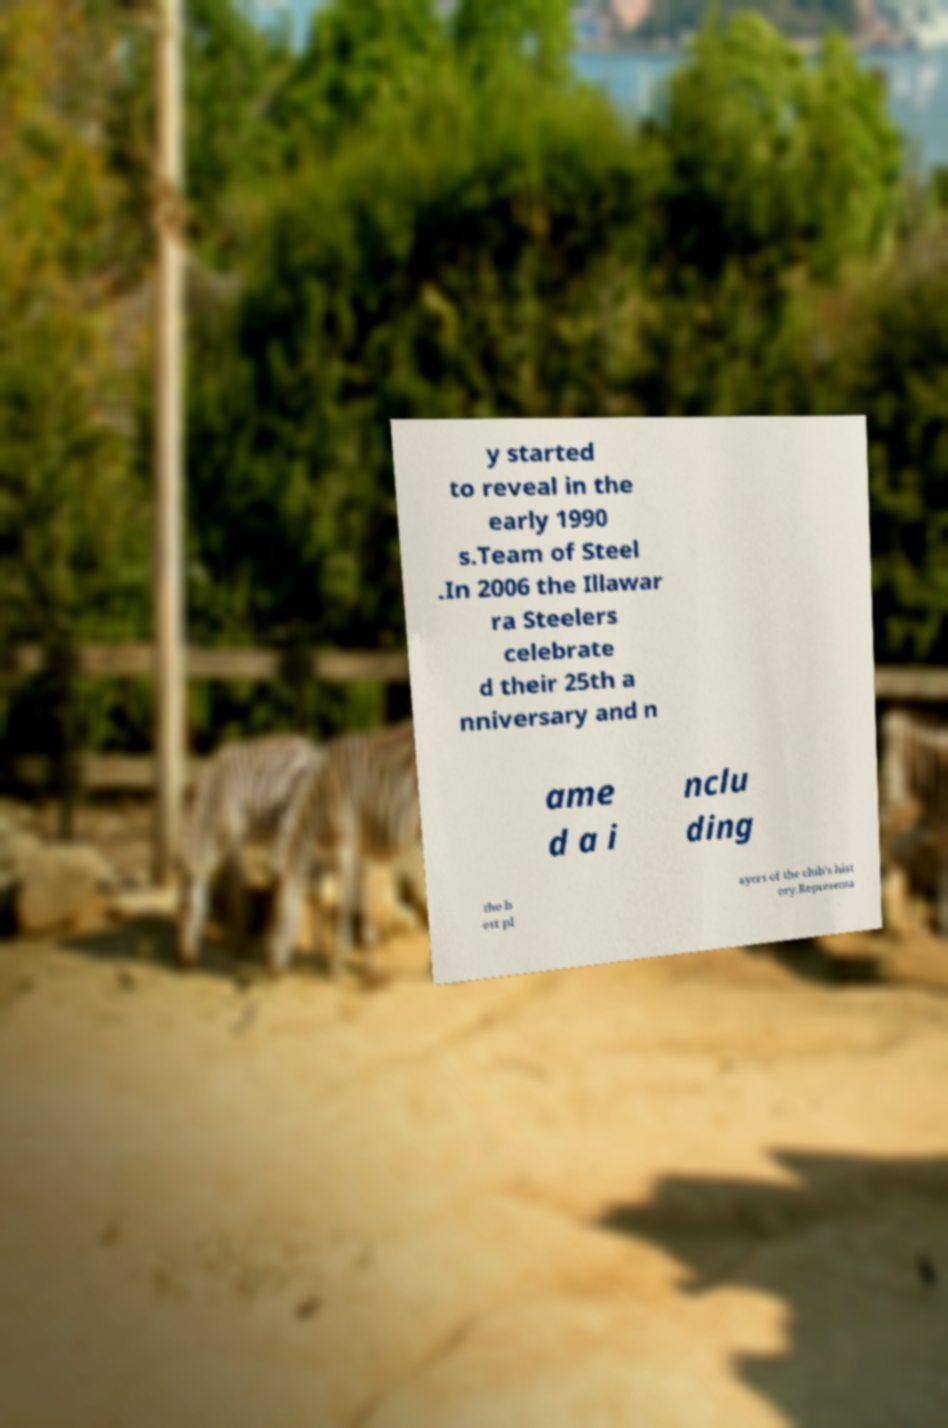What messages or text are displayed in this image? I need them in a readable, typed format. y started to reveal in the early 1990 s.Team of Steel .In 2006 the Illawar ra Steelers celebrate d their 25th a nniversary and n ame d a i nclu ding the b est pl ayers of the club's hist ory.Representa 